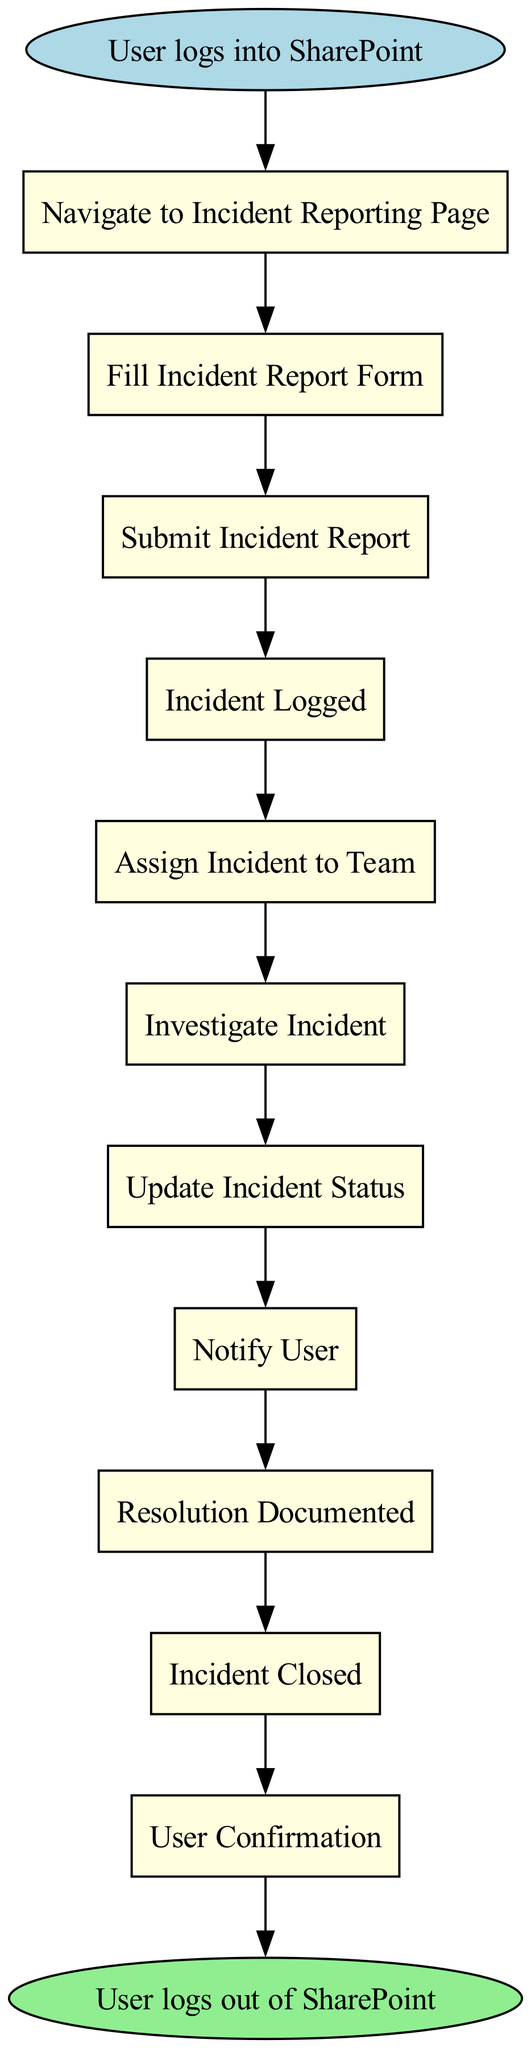What is the first action in the diagram? The first action node after the start node is "Navigate to Incident Reporting Page." It is the first step that occurs according to the flow.
Answer: Navigate to Incident Reporting Page How many actions are there in total? The diagram contains a total of 11 action nodes, which can be counted from the list of actions provided in the data before reaching the end node.
Answer: 11 What action occurs immediately after "Fill Incident Report Form"? The action that follows "Fill Incident Report Form" is "Submit Incident Report." This can be determined by the sequential connection in the diagram's flow.
Answer: Submit Incident Report Which team is responsible for investigating the incident? The resolution team is responsible for investigating the incident as specified in the action node "Investigate Incident." It indicates who performs the investigation.
Answer: Resolution Team What is the last action performed before logging out of SharePoint? The final action before the end node is "User Confirmation." This step confirms that it follows the closure of the incident, leading to the logout.
Answer: User Confirmation How many notifications does the user receive throughout the process? The user receives one notification, specifically during the "Notify User" action. There is only one mention of notification in the flow.
Answer: One Which action generates a unique Incident ID? The action "Incident Logged" is responsible for generating a unique Incident ID as indicated in its description within the diagram's flow of events.
Answer: Incident Logged What action must the user perform to complete the incident resolution process? The user must perform "User Confirmation" to complete the incident resolution process, ensuring they agree with the final resolution documented by the team.
Answer: User Confirmation Which action indicates the closure of the incident? The action "Incident Closed" indicates that the incident has been formally closed, representing an important milestone in the incident resolution process.
Answer: Incident Closed 